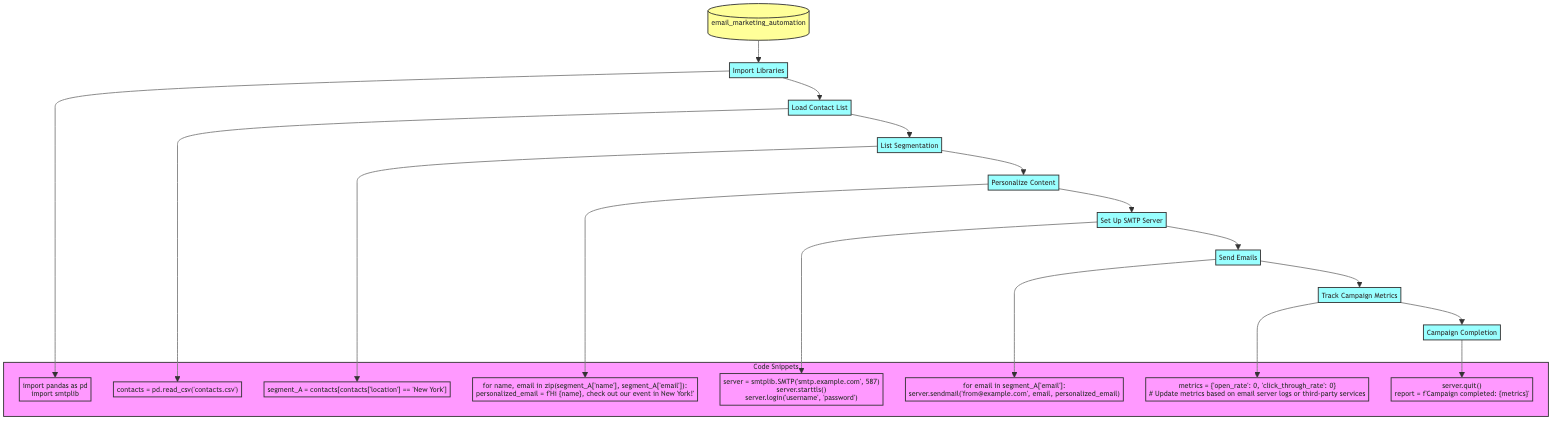What is the first step in the Email Marketing Automation process? The first step shown in the flowchart is "Import Libraries". It is the initial action taken before proceeding to other steps in the process.
Answer: Import Libraries How many steps are there in the process? The flowchart displays a total of eight steps. Counting each individual action shows that there are eight distinct steps from "Import Libraries" to "Campaign Completion".
Answer: Eight Which step follows "List Segmentation"? The step that follows "List Segmentation" is "Personalize Content". This can be observed by tracing the arrows in the flowchart from "List Segmentation" to the next node.
Answer: Personalize Content What type of information is being tracked in "Track Campaign Metrics"? The information being tracked includes key metrics such as open rate and click-through rate. This is explicitly mentioned in the description of the "Track Campaign Metrics" step.
Answer: Open rate and click-through rate What does the SMTP server settings entail in the process? The SMTP server settings involve configuring the server, starting TLS, and logging in with a username and password. This is detailed in the step "Set Up SMTP Server".
Answer: Configure server, start TLS, login Explain the purpose of personalizing email content. The purpose is to customize email content based on the segmented list, which enhances engagement by making the emails more relevant to each recipient. This is captured in the "Personalize Content" step.
Answer: Enhance engagement After sending emails, what is the next step in the flowchart? The next step after sending emails is "Track Campaign Metrics". This follows directly in the sequence of the process reflected in the flowchart.
Answer: Track Campaign Metrics What is generated at the end of the Email Marketing Automation process? A report is generated at the end of the process, summarizing the completion of the campaign along with the tracked metrics. This is described in the "Campaign Completion" step.
Answer: Report Which programming library is imported for data manipulation? The programming library imported for data manipulation is pandas. This is stated in the "Import Libraries" step of the flowchart.
Answer: Pandas 